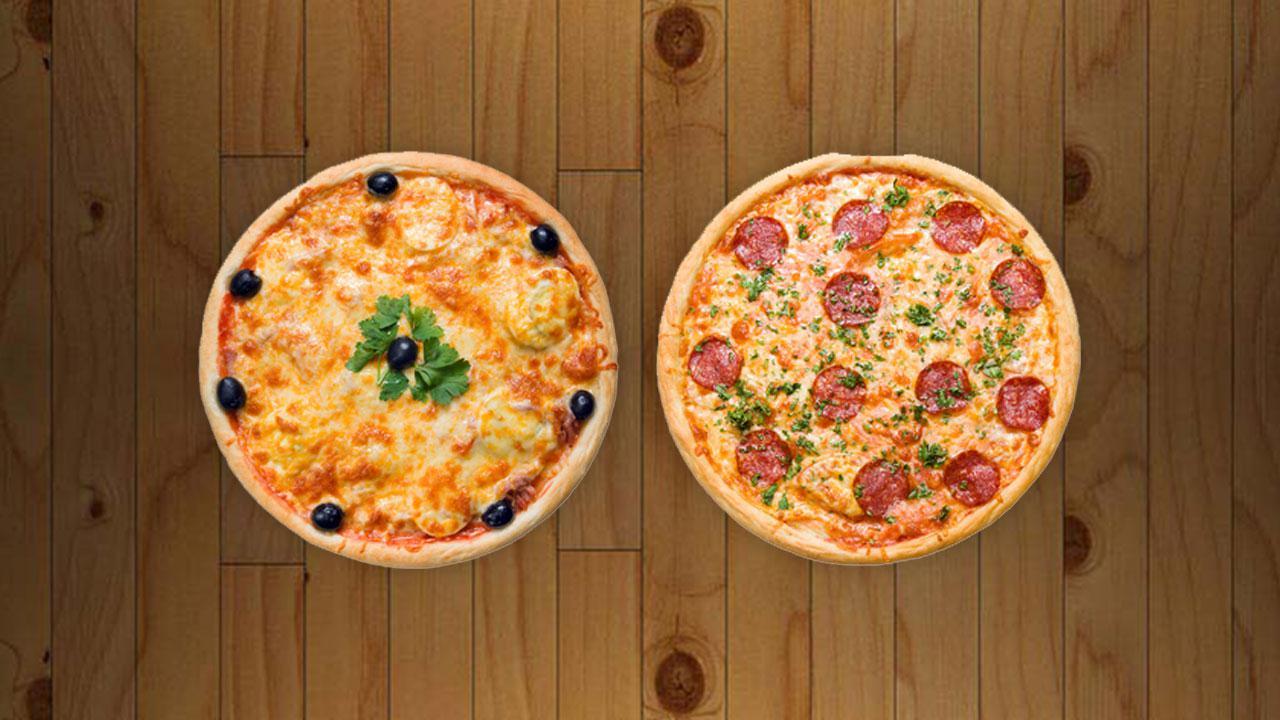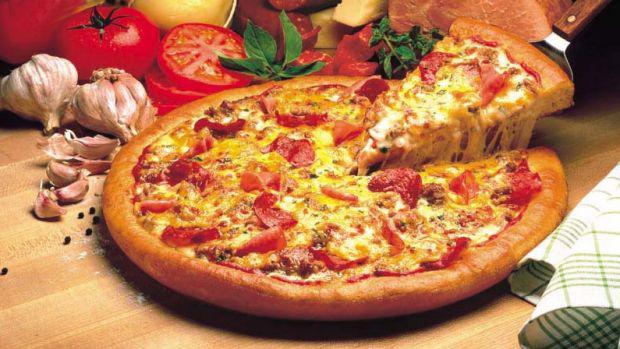The first image is the image on the left, the second image is the image on the right. Considering the images on both sides, is "In the left image a slice is being lifted off the pizza." valid? Answer yes or no. No. The first image is the image on the left, the second image is the image on the right. Evaluate the accuracy of this statement regarding the images: "Four pizzas are visible.". Is it true? Answer yes or no. No. 